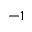<formula> <loc_0><loc_0><loc_500><loc_500>^ { - 1 }</formula> 